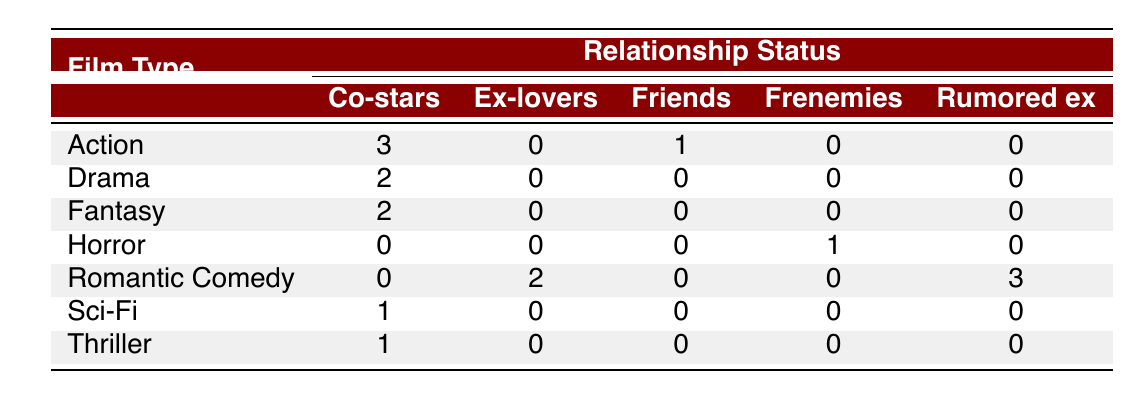What is the total number of collaborations in Action films? To find the total number of collaborations in Action films, we look at the corresponding row for Action. There are 3 collaborations with co-stars and 1 collaboration with friends, so we add them: 3 + 1 = 4.
Answer: 4 How many Romatic Comedy collaborations were with Ex-lovers? The Romantic Comedy row shows that there were 2 collaborations with Ex-lovers.
Answer: 2 Is it true that all collaborations in Horror films were with Frenemies? In the Horror row, there is 1 collaboration but it is listed under Frenemies, so yes, all collaborations in Horror films were with Frenemies.
Answer: Yes What is the average number of collaborations in Drama films? There are 2 films listed as Drama (one with Leonardo DiCaprio and one with Natalie Portman), with each having 1 collaboration. Adding them gives us 1 + 1 = 2. To find the average, we divide the sum by the number of Drama films: 2 / 2 = 1.
Answer: 1 Which film type has the highest number of collaborations with co-stars? Looking at the co-stars column across all rows, Action has the highest collaborations, which is 3.
Answer: Action 